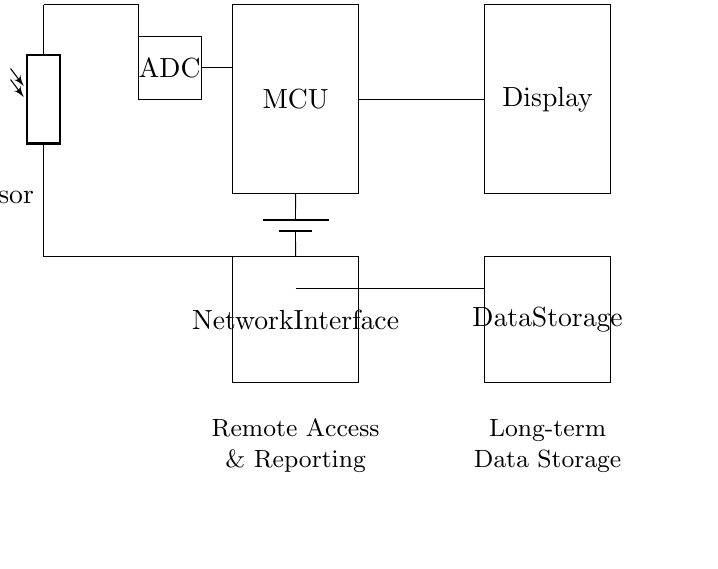What is the main function of the IR sensor? The IR sensor detects foot traffic by measuring changes in infrared light intensity as people pass in front of it.
Answer: Foot traffic detection What component provides power to the circuit? The component providing power in the circuit is the battery, which supplies necessary voltage to operate the other components.
Answer: Battery What type of microcontroller is used in this circuit? The specific type isn't detailed, but it is referred to generically as a microcontroller (MCU), which processes the data from the IR sensor.
Answer: Microcontroller How many data storage units are in the circuit? There is one data storage unit indicated in the circuit, which is represented as a rectangular shape labeled 'Data Storage.'
Answer: One What is the purpose of the ADC in this circuit? The ADC's purpose is to convert the analog signal from the IR sensor into a digital signal that can be processed by the microcontroller.
Answer: Analog-to-digital conversion Where does the data from the microcontroller go? The data from the microcontroller is sent to the display and long-term data storage, allowing for real-time viewing and archiving of traffic data.
Answer: Display and data storage 